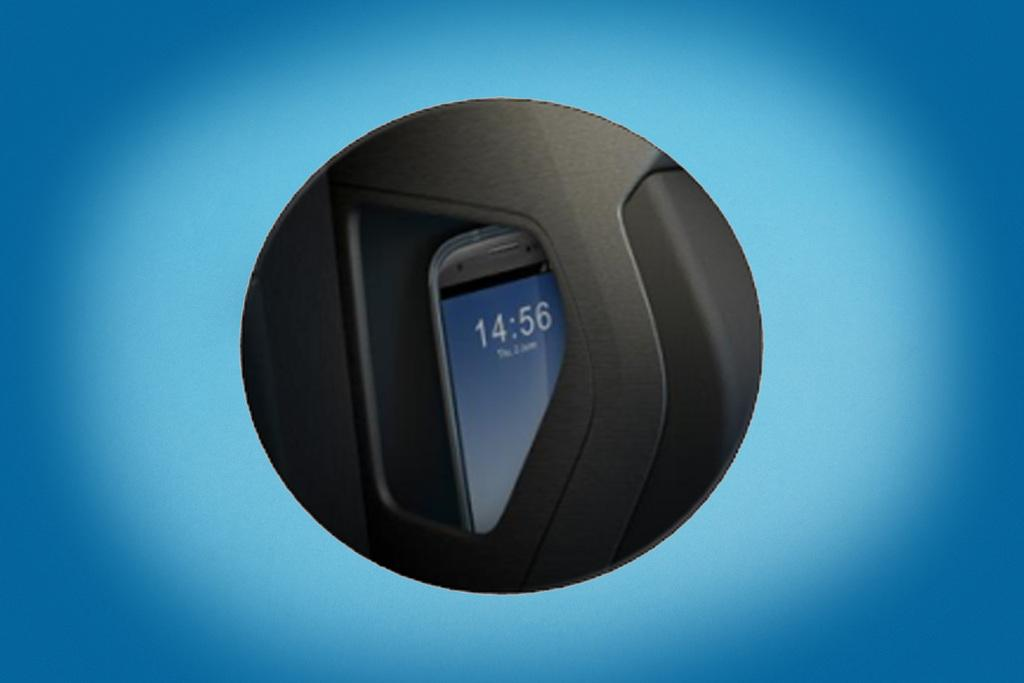<image>
Give a short and clear explanation of the subsequent image. A cell phone displays 14:56 on a blue background. 